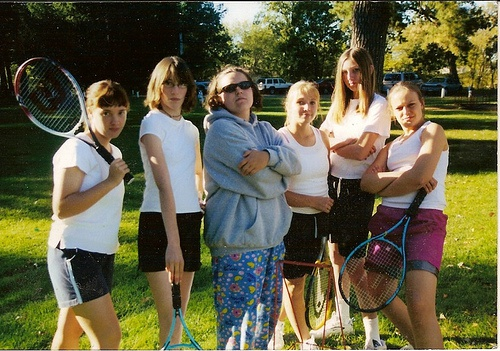Describe the objects in this image and their specific colors. I can see people in black, gray, and blue tones, people in black, maroon, and gray tones, people in black, ivory, olive, and darkgray tones, people in black, gray, and darkgray tones, and people in black, ivory, tan, and maroon tones in this image. 